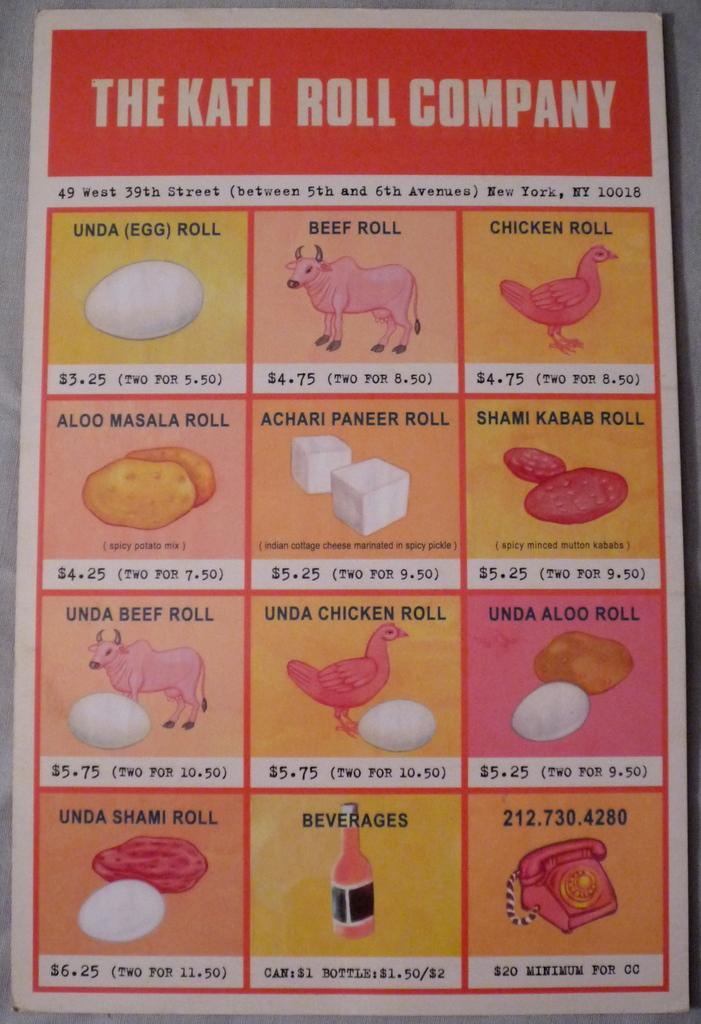What is the main object in the image? There is a menu card in the image. Where is the menu card placed? The menu card is placed on an object. What type of information can be found on the menu card? The menu card contains pictures, words, and numbers. How does the seed on the menu card affect the taste of the food? There is no seed present on the menu card; it contains pictures, words, and numbers. 